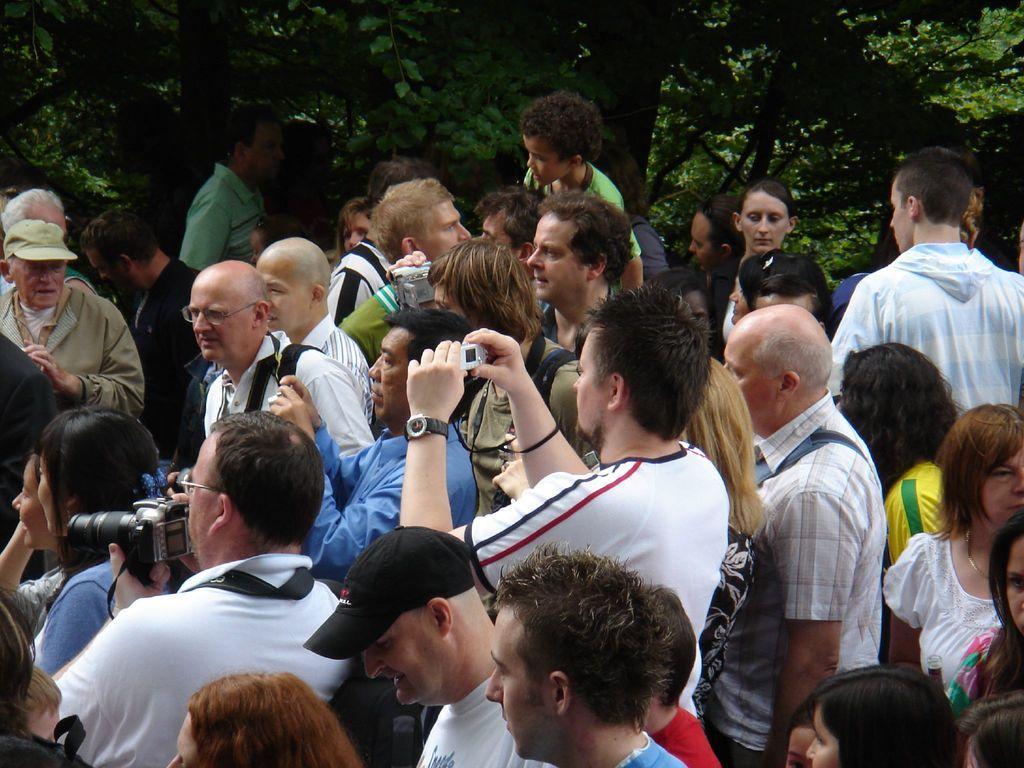Can you describe this image briefly? In the picture I can see a group of people are standing among them some are holding cameras and some other objects in hands. In the background I can see trees. 